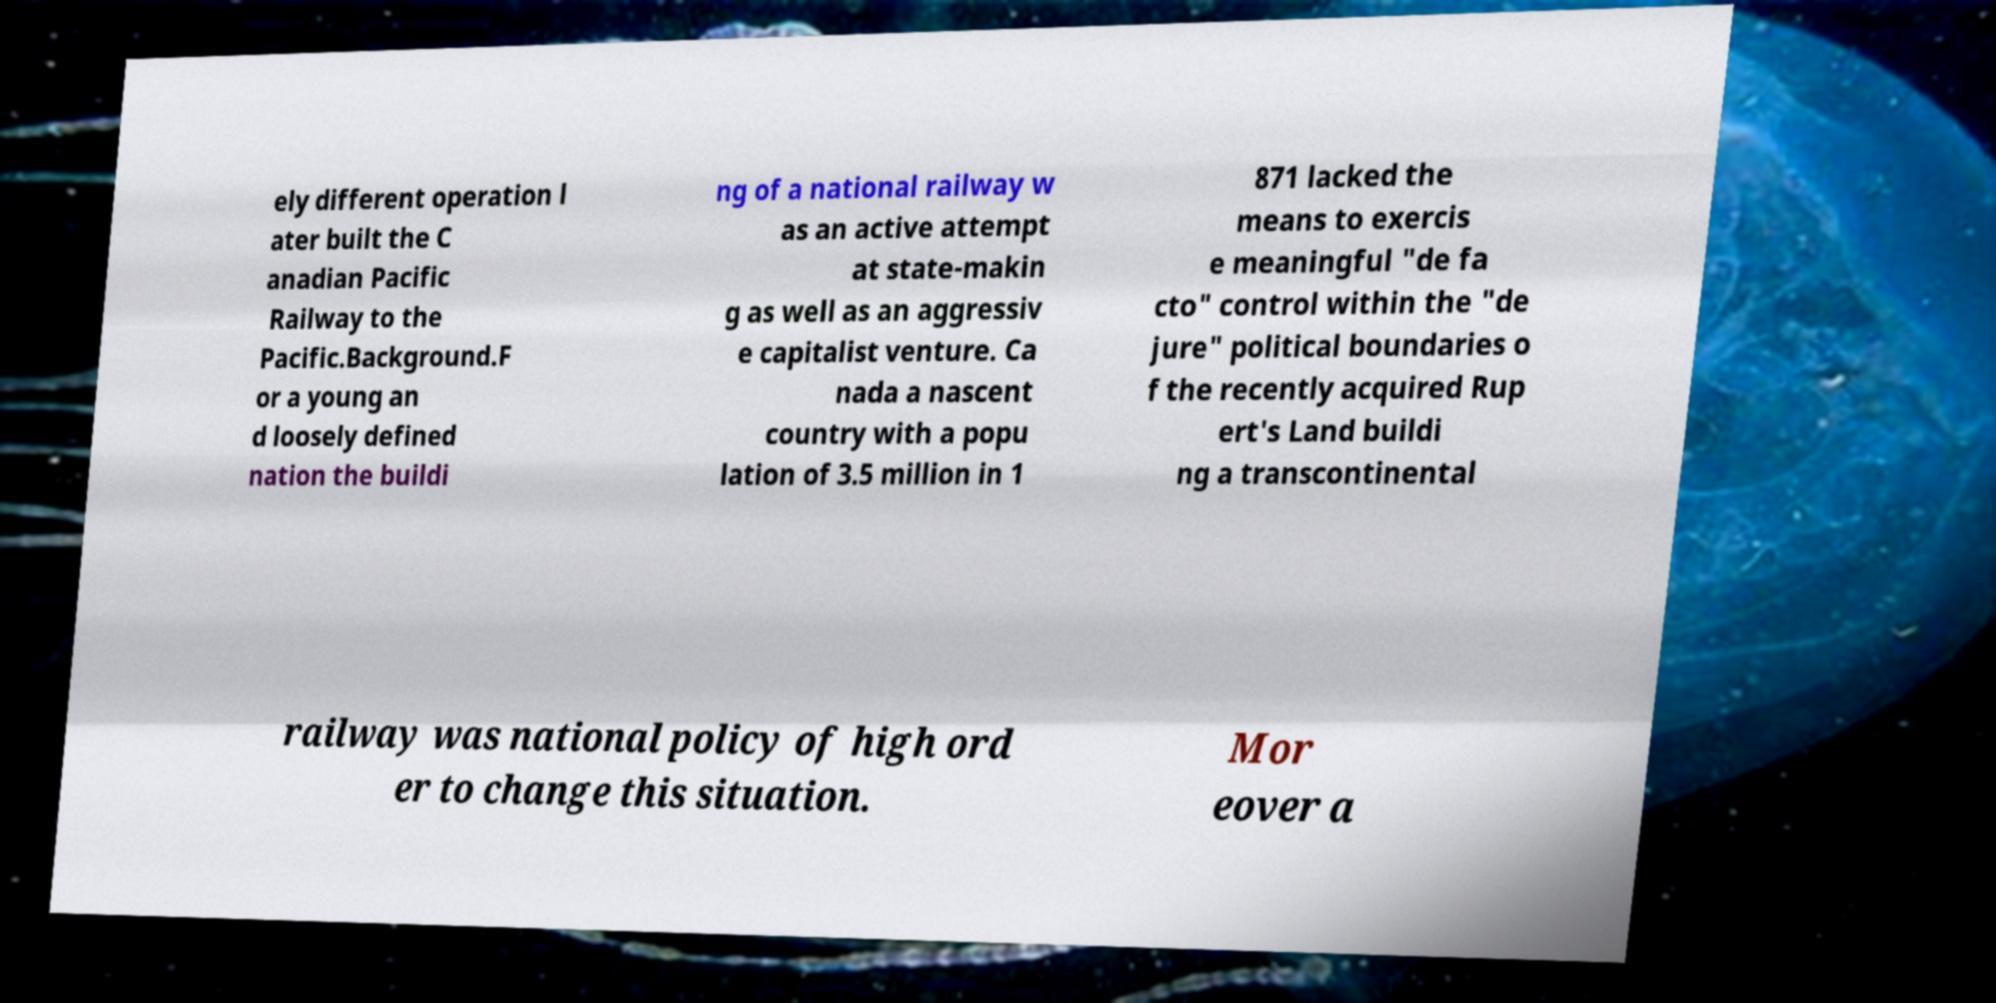Please identify and transcribe the text found in this image. ely different operation l ater built the C anadian Pacific Railway to the Pacific.Background.F or a young an d loosely defined nation the buildi ng of a national railway w as an active attempt at state-makin g as well as an aggressiv e capitalist venture. Ca nada a nascent country with a popu lation of 3.5 million in 1 871 lacked the means to exercis e meaningful "de fa cto" control within the "de jure" political boundaries o f the recently acquired Rup ert's Land buildi ng a transcontinental railway was national policy of high ord er to change this situation. Mor eover a 